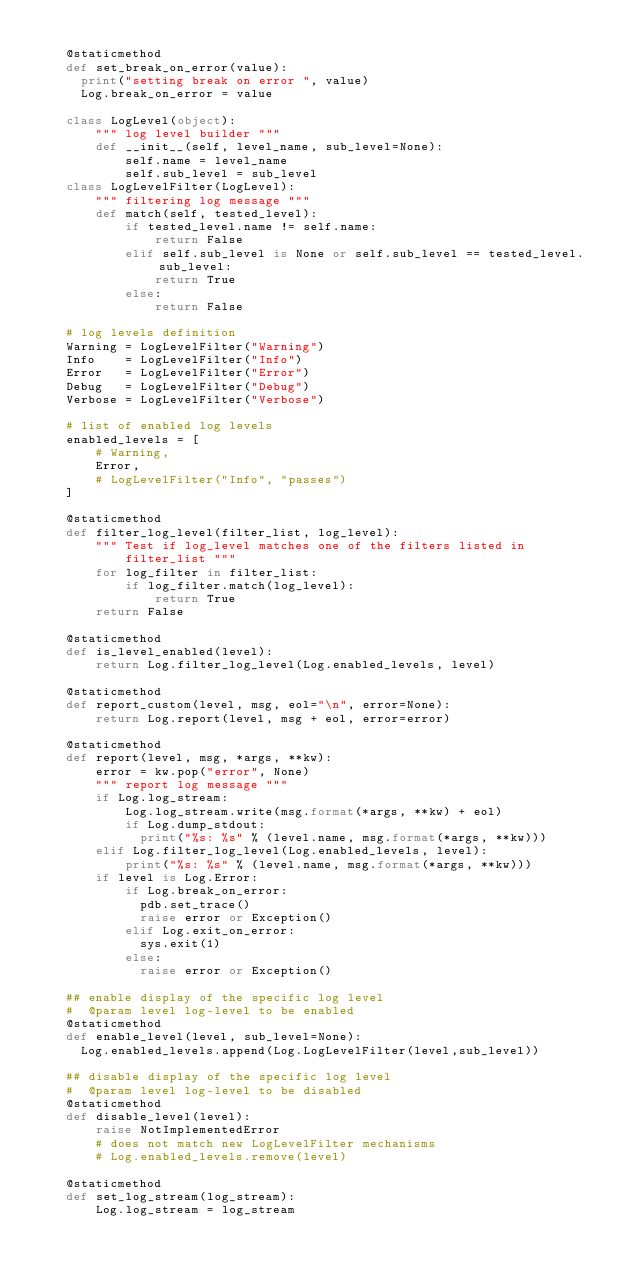<code> <loc_0><loc_0><loc_500><loc_500><_Python_>
    @staticmethod
    def set_break_on_error(value):
      print("setting break on error ", value)
      Log.break_on_error = value

    class LogLevel(object):
        """ log level builder """
        def __init__(self, level_name, sub_level=None):
            self.name = level_name
            self.sub_level = sub_level
    class LogLevelFilter(LogLevel):
        """ filtering log message """
        def match(self, tested_level):
            if tested_level.name != self.name:
                return False
            elif self.sub_level is None or self.sub_level == tested_level.sub_level:
                return True
            else:
                return False

    # log levels definition
    Warning = LogLevelFilter("Warning")
    Info    = LogLevelFilter("Info")
    Error   = LogLevelFilter("Error")
    Debug   = LogLevelFilter("Debug")
    Verbose = LogLevelFilter("Verbose")

    # list of enabled log levels
    enabled_levels = [
        # Warning,
        Error,
        # LogLevelFilter("Info", "passes")
    ]

    @staticmethod
    def filter_log_level(filter_list, log_level):
        """ Test if log_level matches one of the filters listed in
            filter_list """
        for log_filter in filter_list:
            if log_filter.match(log_level):
                return True
        return False

    @staticmethod
    def is_level_enabled(level):
        return Log.filter_log_level(Log.enabled_levels, level)

    @staticmethod
    def report_custom(level, msg, eol="\n", error=None):
        return Log.report(level, msg + eol, error=error)

    @staticmethod
    def report(level, msg, *args, **kw):
        error = kw.pop("error", None)
        """ report log message """
        if Log.log_stream:
            Log.log_stream.write(msg.format(*args, **kw) + eol)
            if Log.dump_stdout:
              print("%s: %s" % (level.name, msg.format(*args, **kw)))
        elif Log.filter_log_level(Log.enabled_levels, level):
            print("%s: %s" % (level.name, msg.format(*args, **kw)))
        if level is Log.Error:
            if Log.break_on_error:
              pdb.set_trace()
              raise error or Exception()
            elif Log.exit_on_error:
              sys.exit(1)
            else:
              raise error or Exception()

    ## enable display of the specific log level
    #  @param level log-level to be enabled
    @staticmethod
    def enable_level(level, sub_level=None):
      Log.enabled_levels.append(Log.LogLevelFilter(level,sub_level))

    ## disable display of the specific log level
    #  @param level log-level to be disabled
    @staticmethod
    def disable_level(level):
        raise NotImplementedError
        # does not match new LogLevelFilter mechanisms
        # Log.enabled_levels.remove(level)

    @staticmethod
    def set_log_stream(log_stream):
        Log.log_stream = log_stream

</code> 